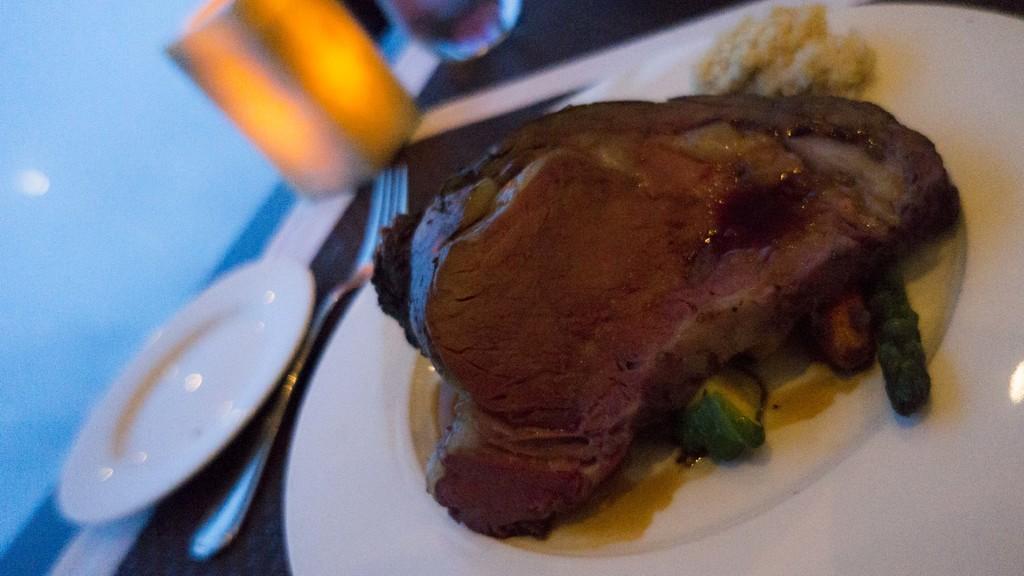How would you summarize this image in a sentence or two? Here we can see plates, fork, food and object. 